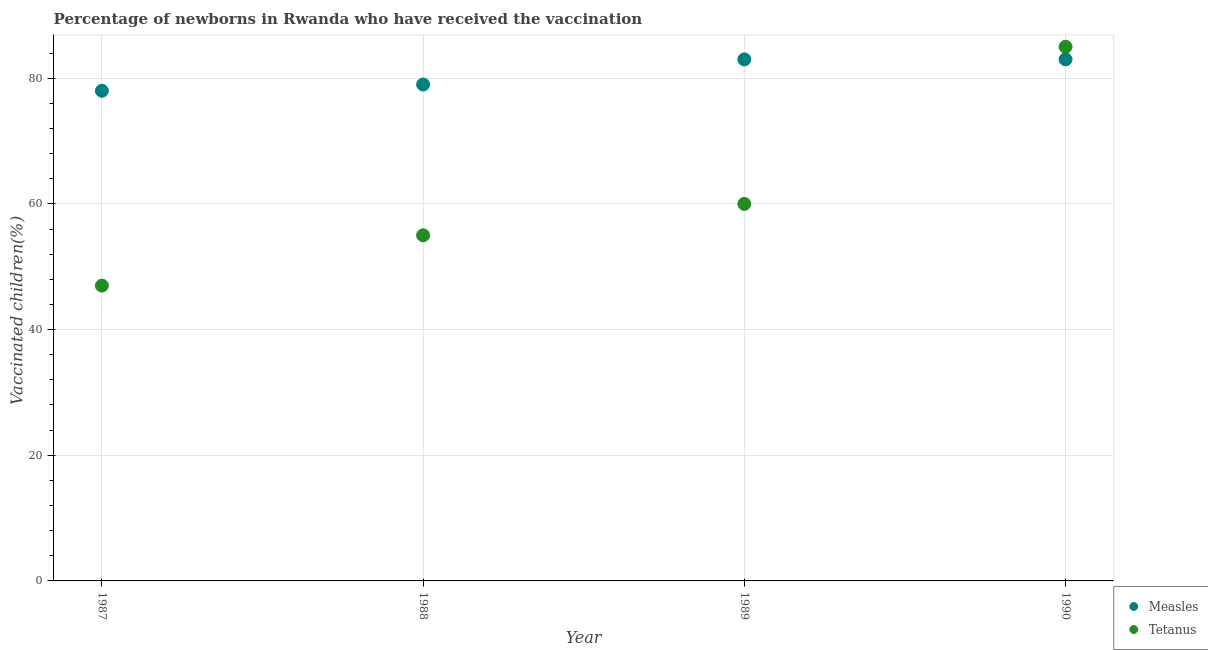Is the number of dotlines equal to the number of legend labels?
Offer a very short reply. Yes. What is the percentage of newborns who received vaccination for measles in 1990?
Your answer should be very brief. 83. Across all years, what is the maximum percentage of newborns who received vaccination for tetanus?
Offer a terse response. 85. Across all years, what is the minimum percentage of newborns who received vaccination for tetanus?
Provide a short and direct response. 47. What is the total percentage of newborns who received vaccination for measles in the graph?
Offer a terse response. 323. What is the difference between the percentage of newborns who received vaccination for tetanus in 1988 and that in 1989?
Provide a succinct answer. -5. What is the difference between the percentage of newborns who received vaccination for measles in 1989 and the percentage of newborns who received vaccination for tetanus in 1990?
Give a very brief answer. -2. What is the average percentage of newborns who received vaccination for measles per year?
Ensure brevity in your answer.  80.75. In the year 1988, what is the difference between the percentage of newborns who received vaccination for measles and percentage of newborns who received vaccination for tetanus?
Give a very brief answer. 24. In how many years, is the percentage of newborns who received vaccination for measles greater than 52 %?
Keep it short and to the point. 4. What is the ratio of the percentage of newborns who received vaccination for measles in 1987 to that in 1990?
Provide a short and direct response. 0.94. Is the percentage of newborns who received vaccination for measles in 1987 less than that in 1988?
Offer a terse response. Yes. What is the difference between the highest and the second highest percentage of newborns who received vaccination for tetanus?
Make the answer very short. 25. What is the difference between the highest and the lowest percentage of newborns who received vaccination for tetanus?
Give a very brief answer. 38. In how many years, is the percentage of newborns who received vaccination for tetanus greater than the average percentage of newborns who received vaccination for tetanus taken over all years?
Offer a very short reply. 1. Is the sum of the percentage of newborns who received vaccination for tetanus in 1987 and 1989 greater than the maximum percentage of newborns who received vaccination for measles across all years?
Offer a very short reply. Yes. Does the percentage of newborns who received vaccination for measles monotonically increase over the years?
Your answer should be very brief. No. Is the percentage of newborns who received vaccination for tetanus strictly greater than the percentage of newborns who received vaccination for measles over the years?
Ensure brevity in your answer.  No. What is the difference between two consecutive major ticks on the Y-axis?
Your answer should be compact. 20. Does the graph contain grids?
Your answer should be very brief. Yes. How many legend labels are there?
Ensure brevity in your answer.  2. How are the legend labels stacked?
Keep it short and to the point. Vertical. What is the title of the graph?
Your response must be concise. Percentage of newborns in Rwanda who have received the vaccination. Does "Foreign Liabilities" appear as one of the legend labels in the graph?
Offer a very short reply. No. What is the label or title of the Y-axis?
Offer a terse response. Vaccinated children(%)
. What is the Vaccinated children(%)
 in Measles in 1988?
Offer a very short reply. 79. What is the Vaccinated children(%)
 of Tetanus in 1988?
Provide a succinct answer. 55. What is the Vaccinated children(%)
 of Tetanus in 1989?
Your response must be concise. 60. What is the Vaccinated children(%)
 of Measles in 1990?
Your response must be concise. 83. What is the Vaccinated children(%)
 in Tetanus in 1990?
Your answer should be compact. 85. Across all years, what is the maximum Vaccinated children(%)
 in Measles?
Make the answer very short. 83. Across all years, what is the minimum Vaccinated children(%)
 of Measles?
Keep it short and to the point. 78. Across all years, what is the minimum Vaccinated children(%)
 in Tetanus?
Offer a very short reply. 47. What is the total Vaccinated children(%)
 of Measles in the graph?
Keep it short and to the point. 323. What is the total Vaccinated children(%)
 of Tetanus in the graph?
Your answer should be very brief. 247. What is the difference between the Vaccinated children(%)
 of Measles in 1987 and that in 1988?
Your answer should be compact. -1. What is the difference between the Vaccinated children(%)
 of Tetanus in 1987 and that in 1989?
Offer a very short reply. -13. What is the difference between the Vaccinated children(%)
 of Tetanus in 1987 and that in 1990?
Make the answer very short. -38. What is the difference between the Vaccinated children(%)
 of Measles in 1988 and that in 1989?
Make the answer very short. -4. What is the difference between the Vaccinated children(%)
 of Tetanus in 1988 and that in 1989?
Offer a terse response. -5. What is the difference between the Vaccinated children(%)
 in Tetanus in 1988 and that in 1990?
Offer a terse response. -30. What is the difference between the Vaccinated children(%)
 of Tetanus in 1989 and that in 1990?
Provide a short and direct response. -25. What is the difference between the Vaccinated children(%)
 of Measles in 1987 and the Vaccinated children(%)
 of Tetanus in 1988?
Ensure brevity in your answer.  23. What is the difference between the Vaccinated children(%)
 of Measles in 1987 and the Vaccinated children(%)
 of Tetanus in 1989?
Your answer should be very brief. 18. What is the difference between the Vaccinated children(%)
 of Measles in 1987 and the Vaccinated children(%)
 of Tetanus in 1990?
Offer a terse response. -7. What is the difference between the Vaccinated children(%)
 in Measles in 1988 and the Vaccinated children(%)
 in Tetanus in 1989?
Offer a terse response. 19. What is the average Vaccinated children(%)
 in Measles per year?
Make the answer very short. 80.75. What is the average Vaccinated children(%)
 in Tetanus per year?
Provide a succinct answer. 61.75. In the year 1987, what is the difference between the Vaccinated children(%)
 in Measles and Vaccinated children(%)
 in Tetanus?
Your answer should be compact. 31. In the year 1988, what is the difference between the Vaccinated children(%)
 in Measles and Vaccinated children(%)
 in Tetanus?
Give a very brief answer. 24. What is the ratio of the Vaccinated children(%)
 of Measles in 1987 to that in 1988?
Offer a terse response. 0.99. What is the ratio of the Vaccinated children(%)
 in Tetanus in 1987 to that in 1988?
Offer a terse response. 0.85. What is the ratio of the Vaccinated children(%)
 in Measles in 1987 to that in 1989?
Your response must be concise. 0.94. What is the ratio of the Vaccinated children(%)
 of Tetanus in 1987 to that in 1989?
Your answer should be compact. 0.78. What is the ratio of the Vaccinated children(%)
 of Measles in 1987 to that in 1990?
Keep it short and to the point. 0.94. What is the ratio of the Vaccinated children(%)
 in Tetanus in 1987 to that in 1990?
Your response must be concise. 0.55. What is the ratio of the Vaccinated children(%)
 in Measles in 1988 to that in 1989?
Your answer should be very brief. 0.95. What is the ratio of the Vaccinated children(%)
 in Measles in 1988 to that in 1990?
Provide a succinct answer. 0.95. What is the ratio of the Vaccinated children(%)
 in Tetanus in 1988 to that in 1990?
Offer a very short reply. 0.65. What is the ratio of the Vaccinated children(%)
 in Tetanus in 1989 to that in 1990?
Your answer should be very brief. 0.71. What is the difference between the highest and the second highest Vaccinated children(%)
 in Tetanus?
Your answer should be very brief. 25. What is the difference between the highest and the lowest Vaccinated children(%)
 of Measles?
Give a very brief answer. 5. What is the difference between the highest and the lowest Vaccinated children(%)
 in Tetanus?
Offer a very short reply. 38. 